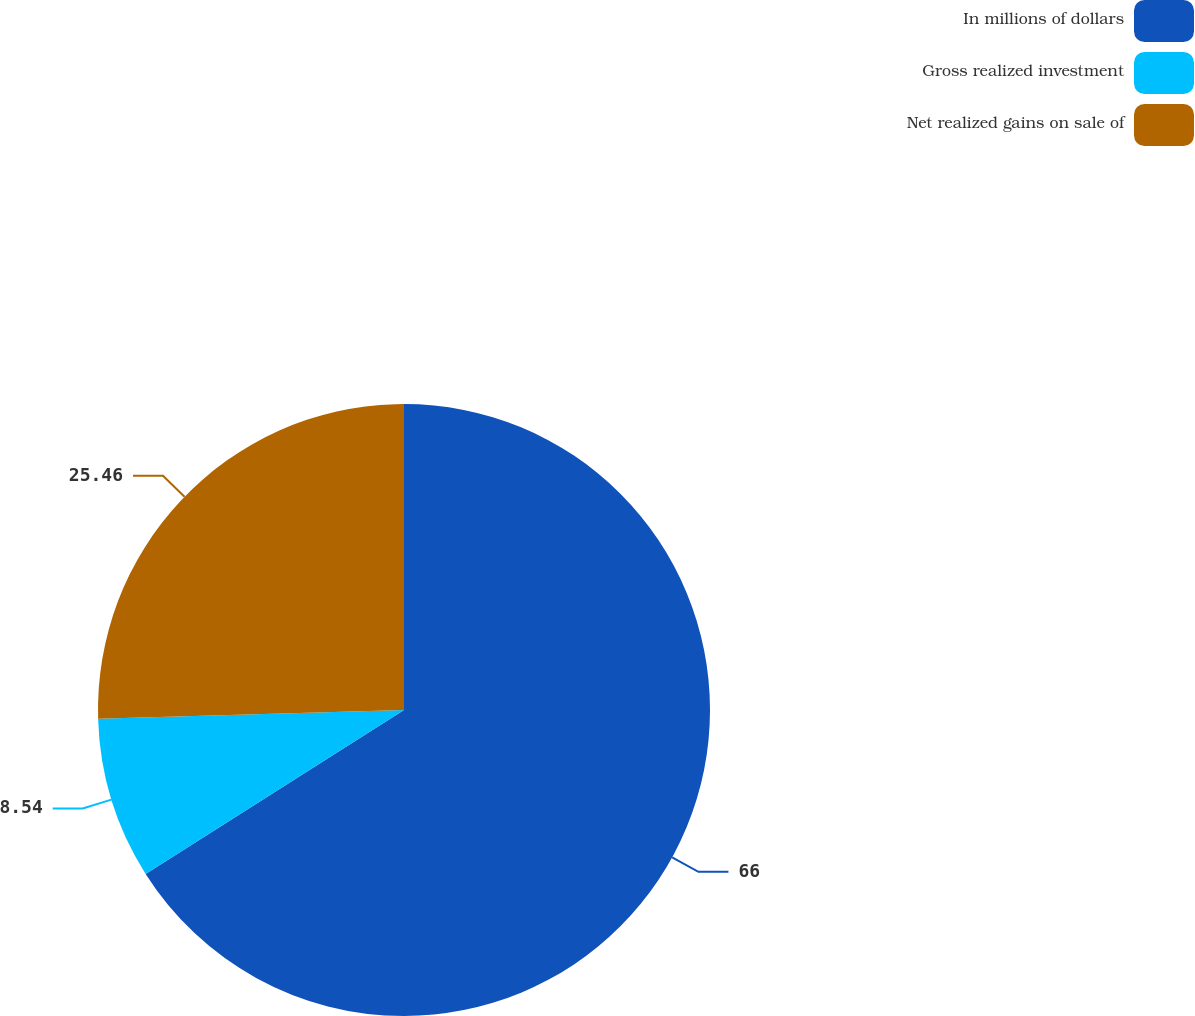Convert chart. <chart><loc_0><loc_0><loc_500><loc_500><pie_chart><fcel>In millions of dollars<fcel>Gross realized investment<fcel>Net realized gains on sale of<nl><fcel>66.0%<fcel>8.54%<fcel>25.46%<nl></chart> 